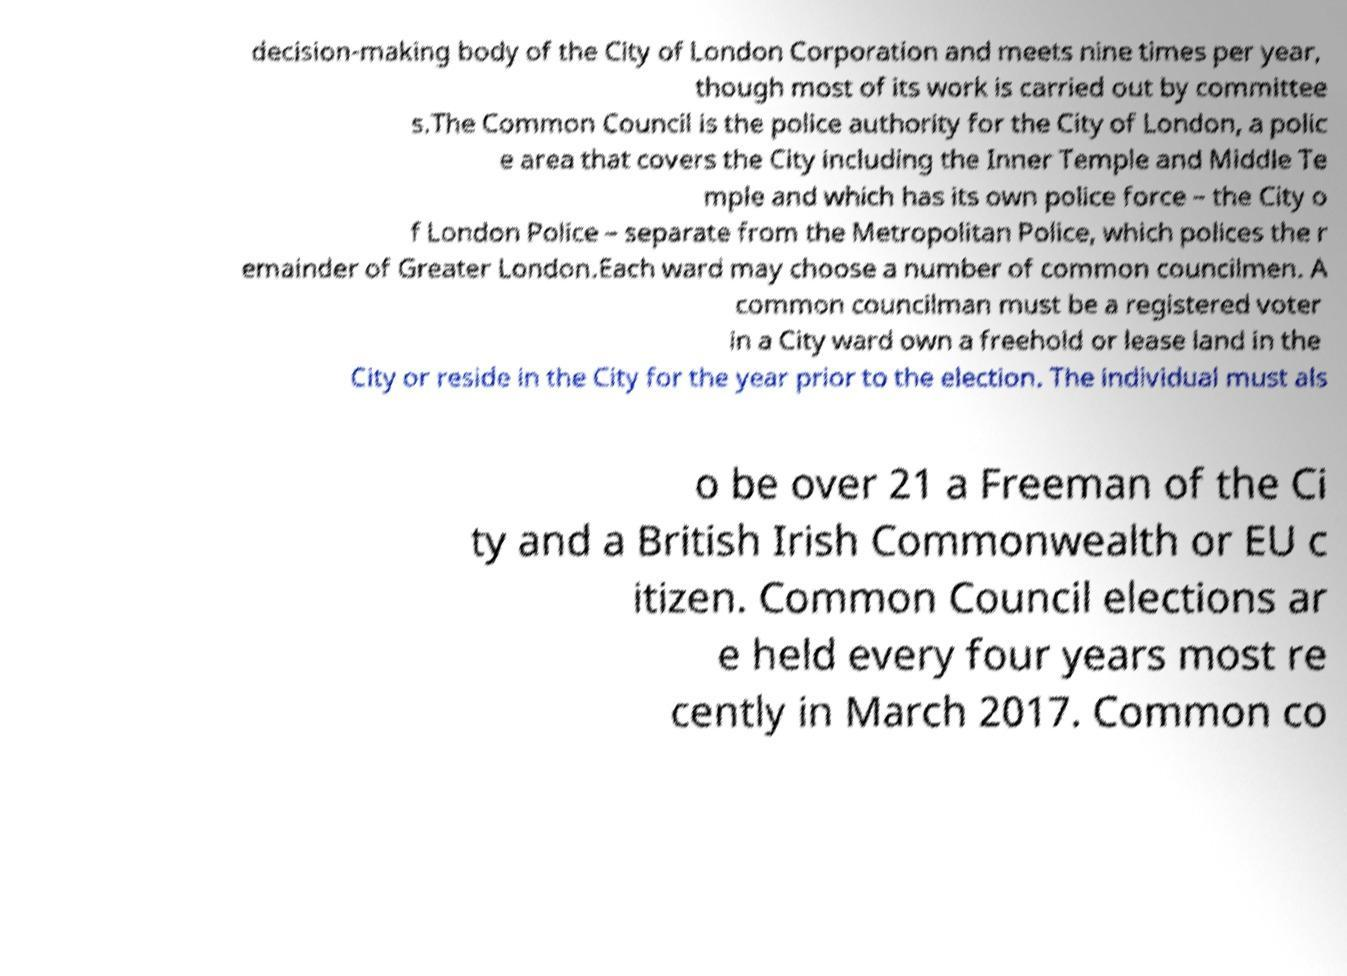Can you read and provide the text displayed in the image?This photo seems to have some interesting text. Can you extract and type it out for me? decision-making body of the City of London Corporation and meets nine times per year, though most of its work is carried out by committee s.The Common Council is the police authority for the City of London, a polic e area that covers the City including the Inner Temple and Middle Te mple and which has its own police force – the City o f London Police – separate from the Metropolitan Police, which polices the r emainder of Greater London.Each ward may choose a number of common councilmen. A common councilman must be a registered voter in a City ward own a freehold or lease land in the City or reside in the City for the year prior to the election. The individual must als o be over 21 a Freeman of the Ci ty and a British Irish Commonwealth or EU c itizen. Common Council elections ar e held every four years most re cently in March 2017. Common co 